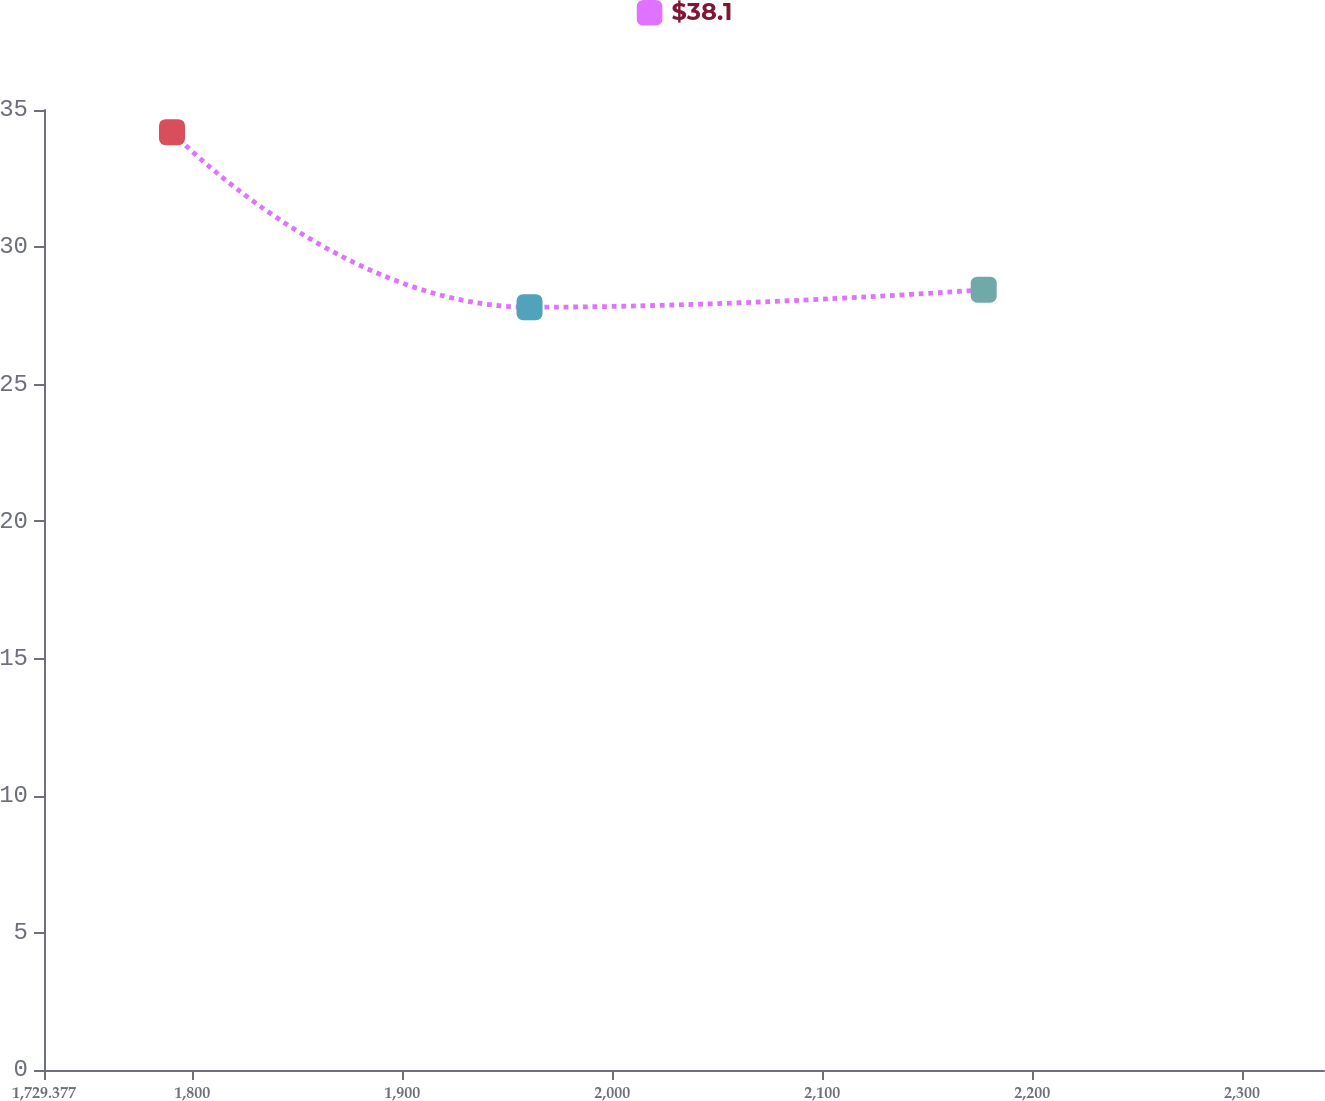Convert chart. <chart><loc_0><loc_0><loc_500><loc_500><line_chart><ecel><fcel>$38.1<nl><fcel>1790.34<fcel>34.19<nl><fcel>1960.63<fcel>27.81<nl><fcel>2176.94<fcel>28.45<nl><fcel>2399.97<fcel>32.49<nl></chart> 